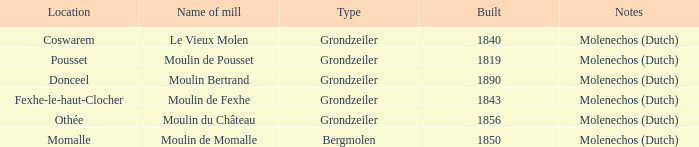What is year Built of the Moulin de Momalle Mill? 1850.0. 